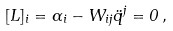<formula> <loc_0><loc_0><loc_500><loc_500>[ L ] _ { i } = \alpha _ { i } - W _ { i j } \ddot { q } ^ { j } = 0 \, ,</formula> 